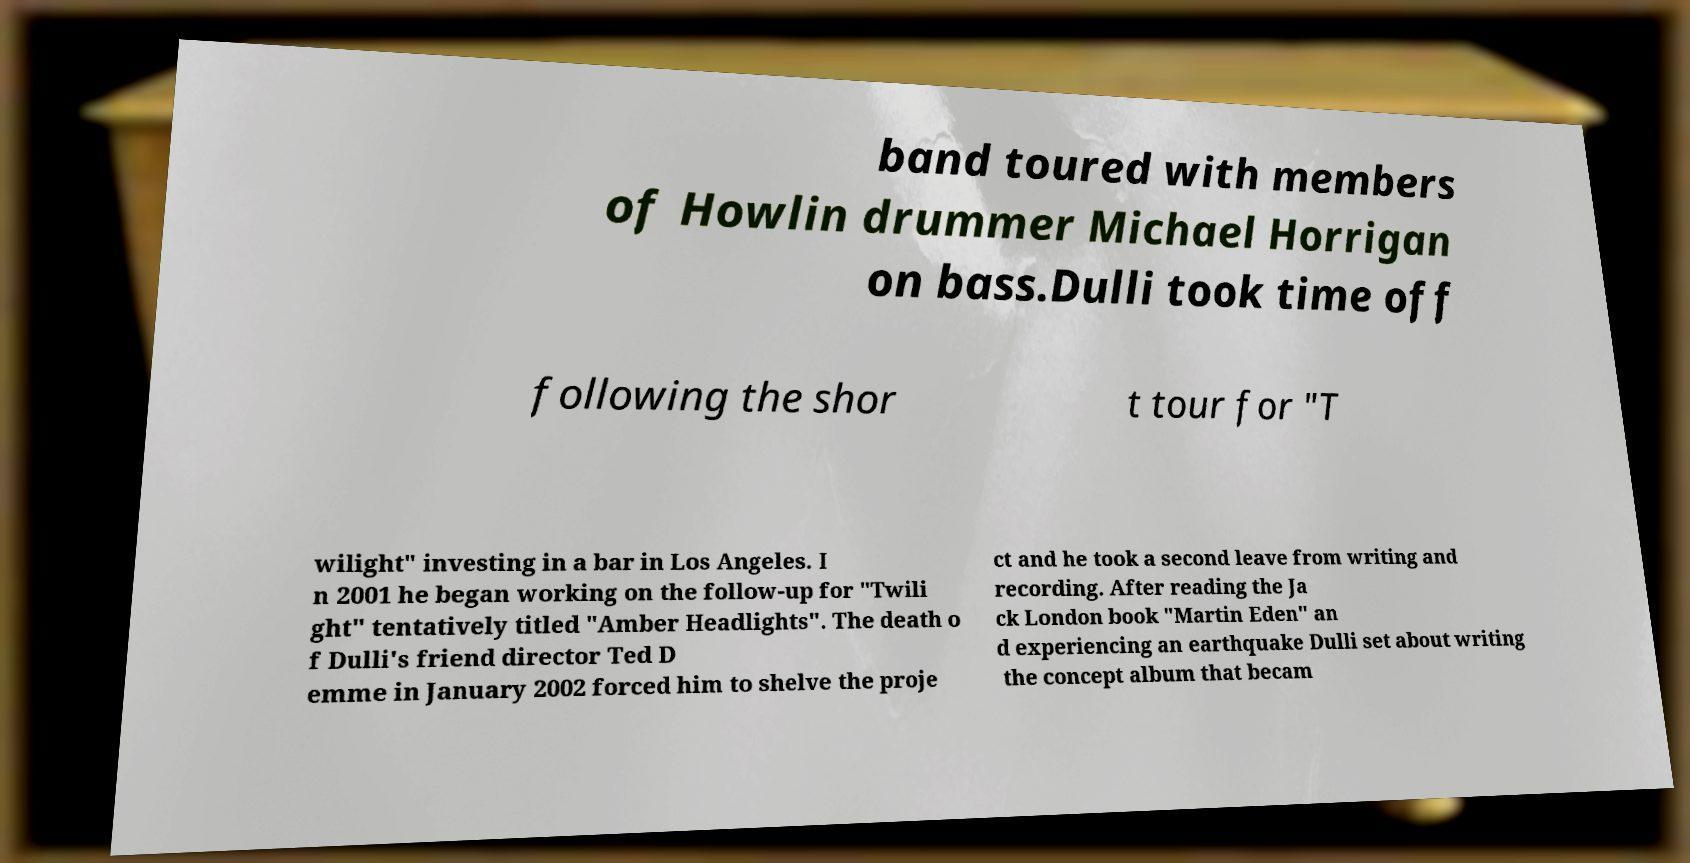Could you extract and type out the text from this image? band toured with members of Howlin drummer Michael Horrigan on bass.Dulli took time off following the shor t tour for "T wilight" investing in a bar in Los Angeles. I n 2001 he began working on the follow-up for "Twili ght" tentatively titled "Amber Headlights". The death o f Dulli's friend director Ted D emme in January 2002 forced him to shelve the proje ct and he took a second leave from writing and recording. After reading the Ja ck London book "Martin Eden" an d experiencing an earthquake Dulli set about writing the concept album that becam 